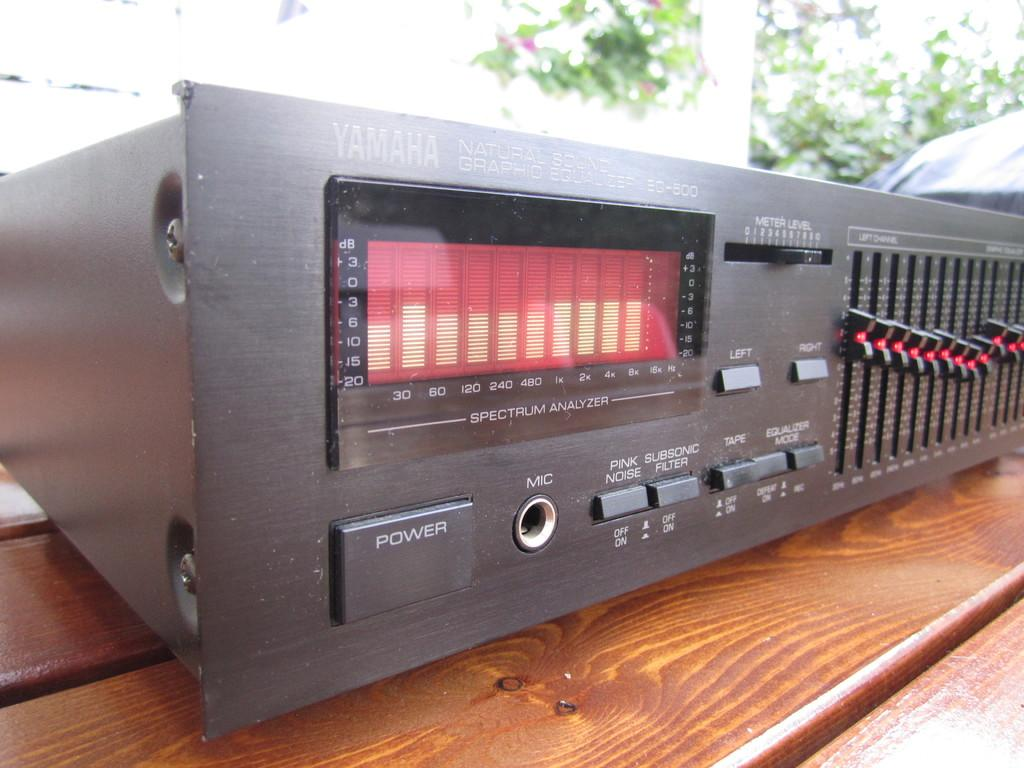What type of device is the main subject in the image? There is a Yamaha equalizer in the image. What is the equalizer placed on? The equalizer is placed on a wooden table. What is the color of the equalizer? The equalizer is black in color. What additional feature is present on the equalizer? There is an analyzer on the equalizer. How can the equalizer be turned on or off? There is a power button on the equalizer. How many buttons are there on the equalizer? There are many buttons on the equalizer. What type of nerve is visible in the image? There is no nerve visible in the image; it features a Yamaha equalizer on a wooden table. What type of grandfather clock is present in the image? There is no grandfather clock present in the image; it features a Yamaha equalizer on a wooden table. 